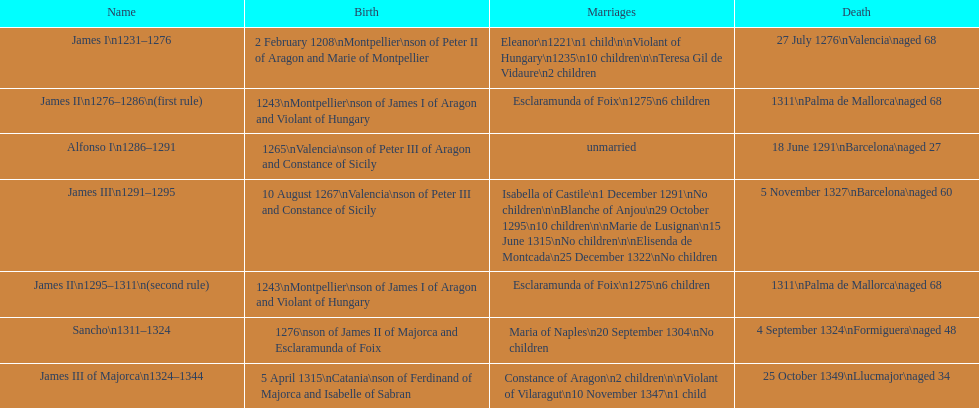Who was the monarch with the greatest number of marital unions? James III 1291-1295. 